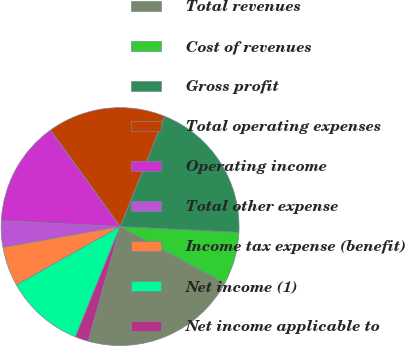Convert chart to OTSL. <chart><loc_0><loc_0><loc_500><loc_500><pie_chart><fcel>Total revenues<fcel>Cost of revenues<fcel>Gross profit<fcel>Total operating expenses<fcel>Operating income<fcel>Total other expense<fcel>Income tax expense (benefit)<fcel>Net income (1)<fcel>Net income applicable to<nl><fcel>21.43%<fcel>7.14%<fcel>19.64%<fcel>16.07%<fcel>14.29%<fcel>3.57%<fcel>5.36%<fcel>10.71%<fcel>1.79%<nl></chart> 